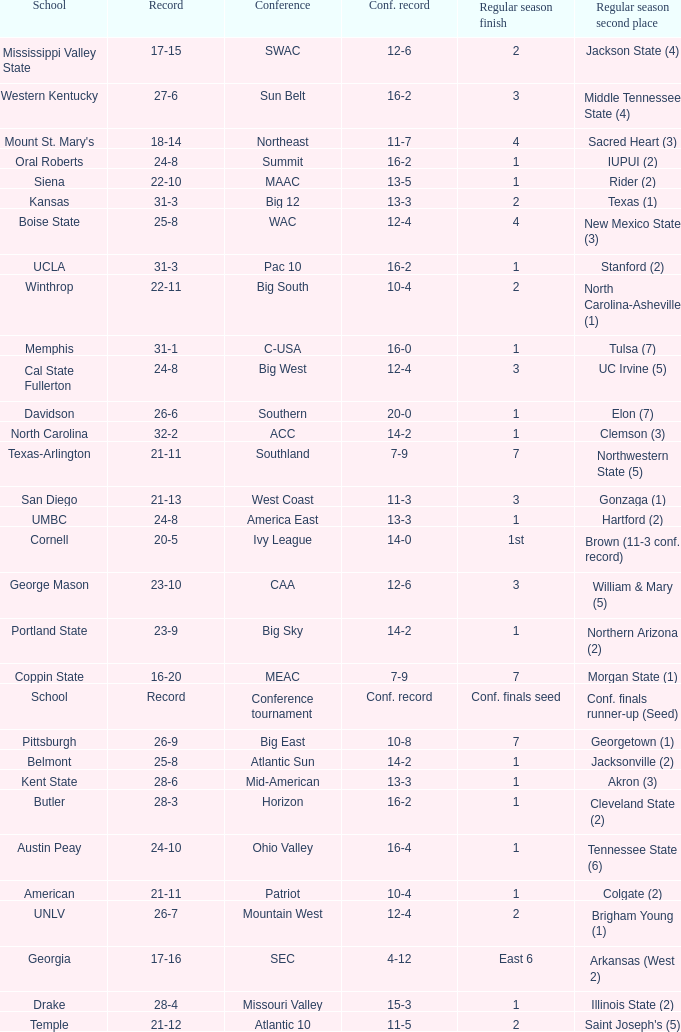Which conference is Belmont in? Atlantic Sun. 